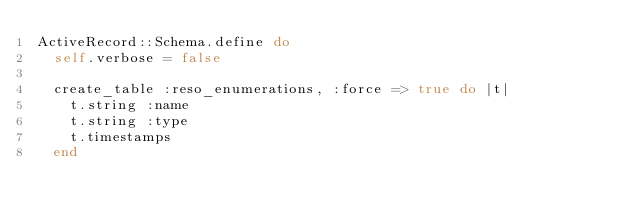Convert code to text. <code><loc_0><loc_0><loc_500><loc_500><_Ruby_>ActiveRecord::Schema.define do
  self.verbose = false

  create_table :reso_enumerations, :force => true do |t|
    t.string :name
    t.string :type
    t.timestamps
  end
</code> 